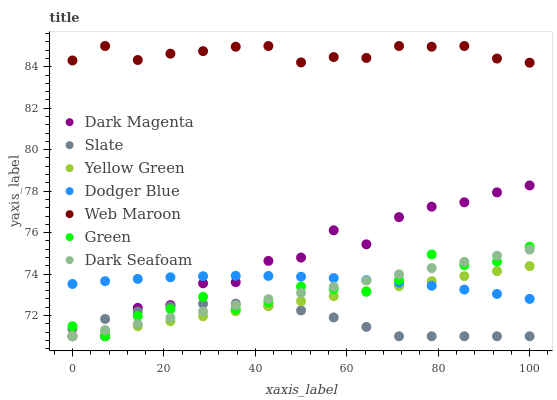Does Slate have the minimum area under the curve?
Answer yes or no. Yes. Does Web Maroon have the maximum area under the curve?
Answer yes or no. Yes. Does Web Maroon have the minimum area under the curve?
Answer yes or no. No. Does Slate have the maximum area under the curve?
Answer yes or no. No. Is Yellow Green the smoothest?
Answer yes or no. Yes. Is Dark Magenta the roughest?
Answer yes or no. Yes. Is Slate the smoothest?
Answer yes or no. No. Is Slate the roughest?
Answer yes or no. No. Does Dark Magenta have the lowest value?
Answer yes or no. Yes. Does Web Maroon have the lowest value?
Answer yes or no. No. Does Web Maroon have the highest value?
Answer yes or no. Yes. Does Slate have the highest value?
Answer yes or no. No. Is Dodger Blue less than Web Maroon?
Answer yes or no. Yes. Is Web Maroon greater than Yellow Green?
Answer yes or no. Yes. Does Dodger Blue intersect Dark Seafoam?
Answer yes or no. Yes. Is Dodger Blue less than Dark Seafoam?
Answer yes or no. No. Is Dodger Blue greater than Dark Seafoam?
Answer yes or no. No. Does Dodger Blue intersect Web Maroon?
Answer yes or no. No. 